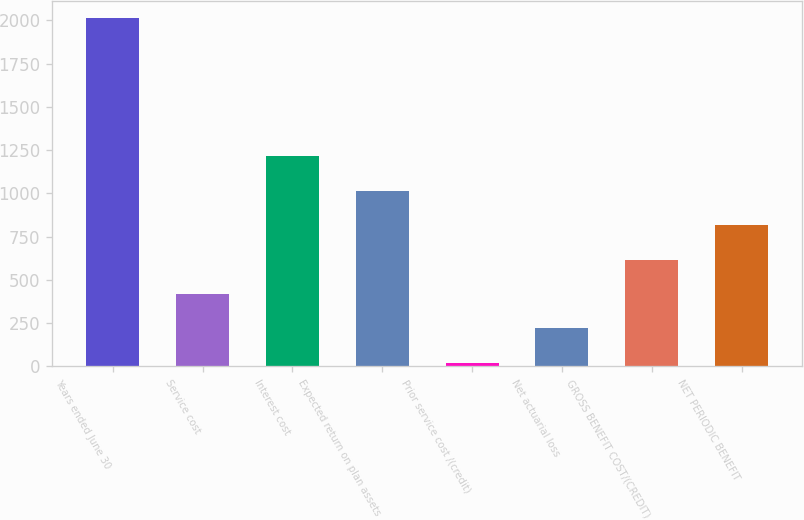<chart> <loc_0><loc_0><loc_500><loc_500><bar_chart><fcel>Years ended June 30<fcel>Service cost<fcel>Interest cost<fcel>Expected return on plan assets<fcel>Prior service cost /(credit)<fcel>Net actuarial loss<fcel>GROSS BENEFIT COST/(CREDIT)<fcel>NET PERIODIC BENEFIT<nl><fcel>2012<fcel>419.2<fcel>1215.6<fcel>1016.5<fcel>21<fcel>220.1<fcel>618.3<fcel>817.4<nl></chart> 